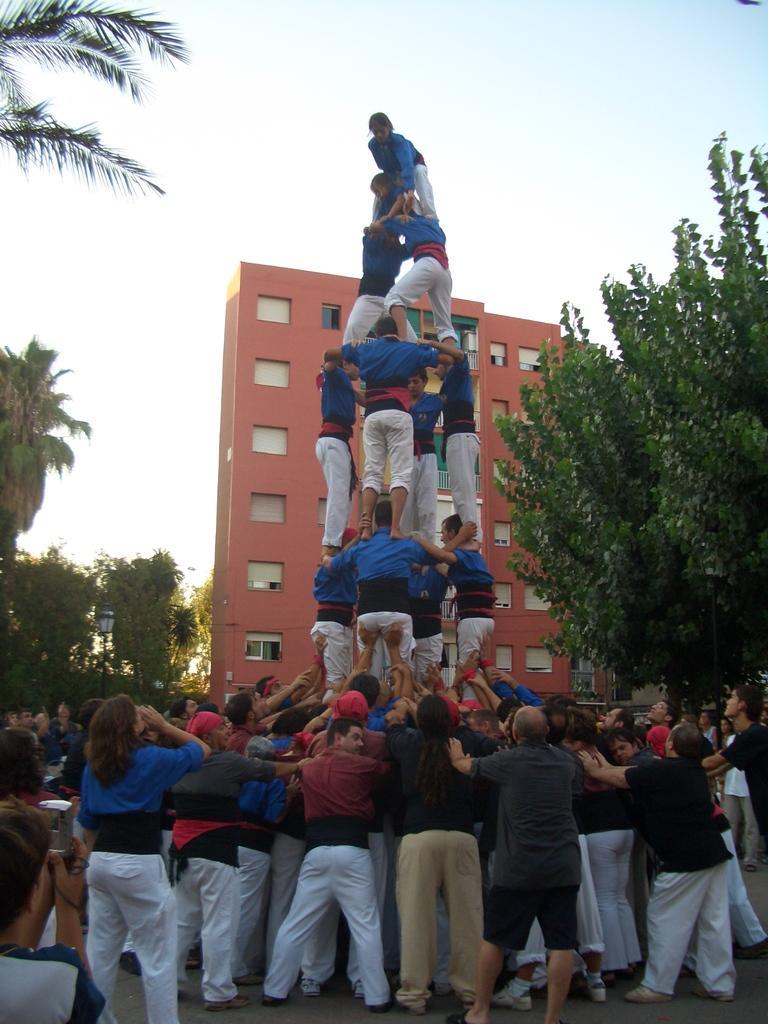Can you describe this image briefly? In the center of the image there are many people are standing one on each other and they are in different costumes. On the left side of the image we can see a few people. Among them, we can see a person is holding some object. In the background, we can see the sky, trees, one building and a pole. 